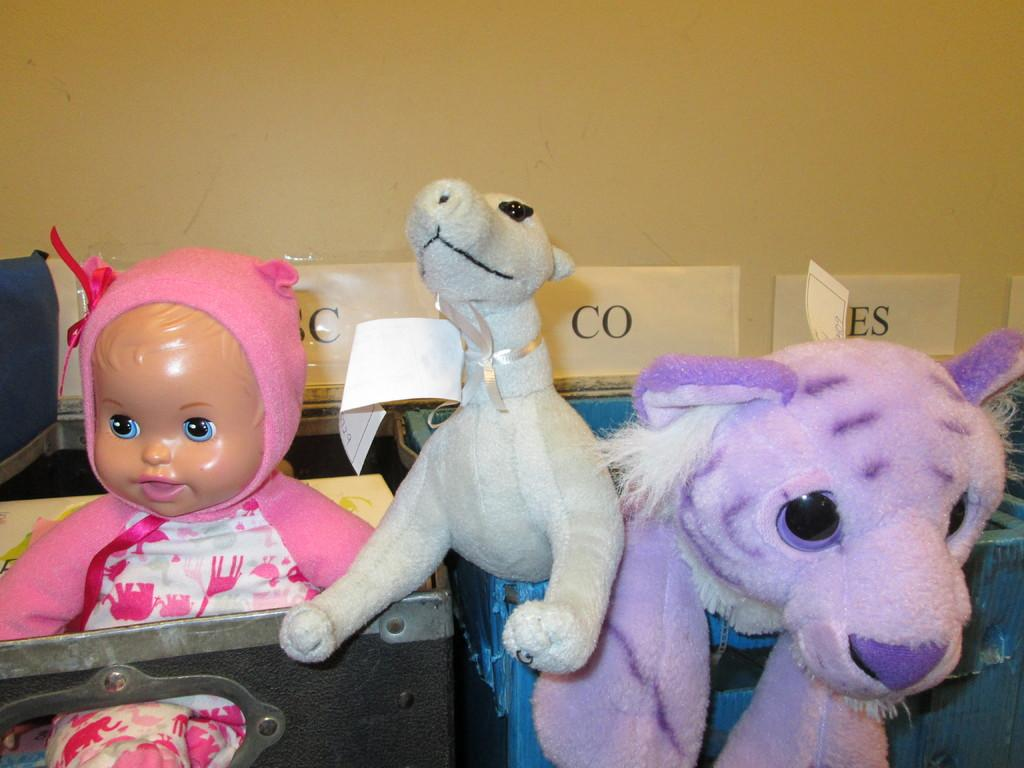What objects can be seen in the image? There are toys and papers in the image. Can you describe the toys in the image? The toys in the image are not specified, but they are present. What can you tell me about the papers in the image? The papers in the image are also not specified, but they are present. What type of leaf is being used as a head covering for the toy in the image? There is no leaf or toy with a head covering present in the image. 